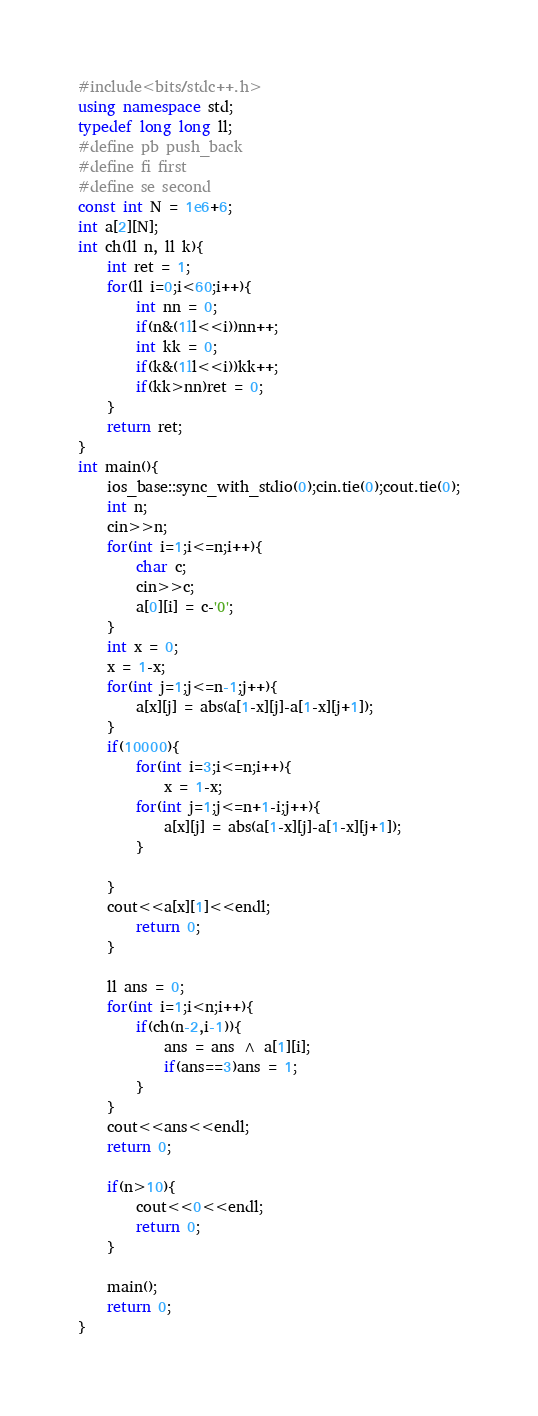<code> <loc_0><loc_0><loc_500><loc_500><_C++_>#include<bits/stdc++.h>
using namespace std; 
typedef long long ll;
#define pb push_back
#define fi first
#define se second 
const int N = 1e6+6;
int a[2][N];
int ch(ll n, ll k){
	int ret = 1;
	for(ll i=0;i<60;i++){
		int nn = 0;
		if(n&(1ll<<i))nn++;
		int kk = 0;
		if(k&(1ll<<i))kk++;
		if(kk>nn)ret = 0;
	}
	return ret;
}
int main(){
	ios_base::sync_with_stdio(0);cin.tie(0);cout.tie(0);
	int n; 
	cin>>n; 
	for(int i=1;i<=n;i++){
		char c; 
		cin>>c;
		a[0][i] = c-'0';
	}
	int x = 0;
	x = 1-x;
	for(int j=1;j<=n-1;j++){
		a[x][j] = abs(a[1-x][j]-a[1-x][j+1]);
	}
	if(10000){
		for(int i=3;i<=n;i++){
			x = 1-x;
		for(int j=1;j<=n+1-i;j++){
			a[x][j] = abs(a[1-x][j]-a[1-x][j+1]);
		}
		
	}
	cout<<a[x][1]<<endl;
		return 0;
	}
	
	ll ans = 0;
	for(int i=1;i<n;i++){
		if(ch(n-2,i-1)){
			ans = ans ^ a[1][i];
			if(ans==3)ans = 1;
		}
	}
	cout<<ans<<endl;
	return 0;

	if(n>10){
		cout<<0<<endl;
		return 0;
	}
	
	main();
	return 0;
}
</code> 